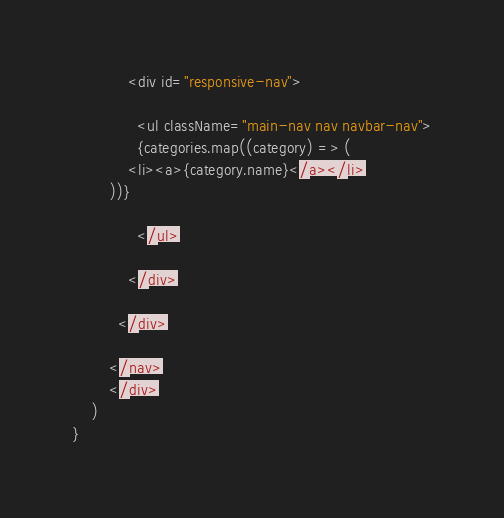Convert code to text. <code><loc_0><loc_0><loc_500><loc_500><_JavaScript_>            <div id="responsive-nav">
              
              <ul className="main-nav nav navbar-nav">
              {categories.map((category) => (
            <li><a>{category.name}</a></li>
        ))}
              
              </ul>
              
            </div>
            
          </div>
          
        </nav>
        </div>
    )
}
</code> 